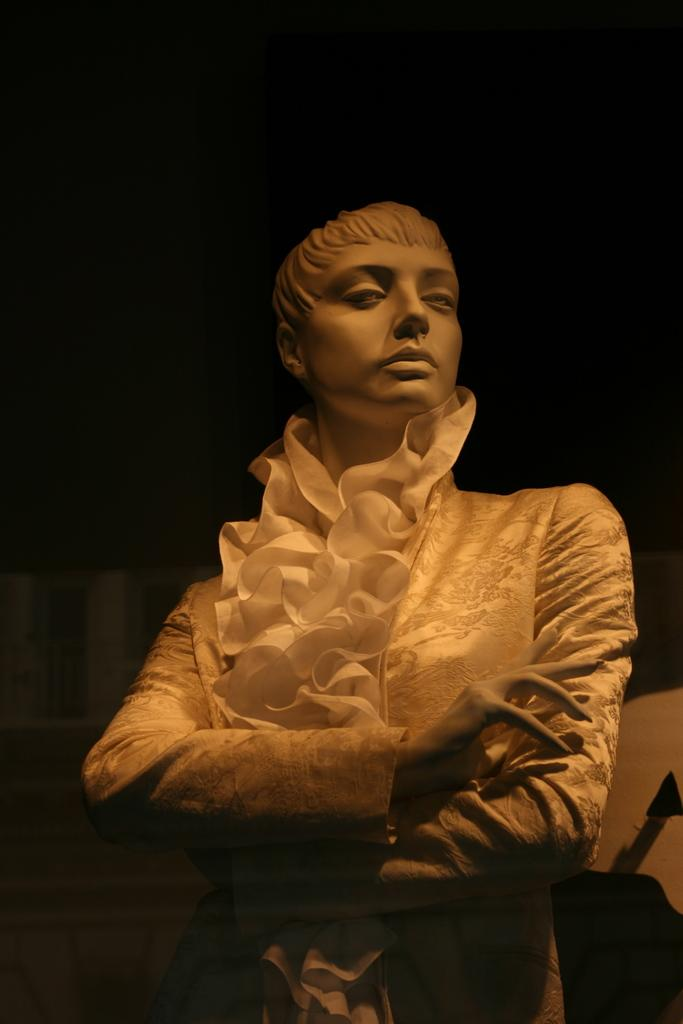What is the main subject of the image? There is a statue in the image. What can be observed about the background of the image? The background of the image is dark. What type of frog can be seen holding a sign in the image? There is no frog or sign present in the image; it features a statue. What is the statue's afterthought in the image? The statue does not have an afterthought, as it is an inanimate object. 